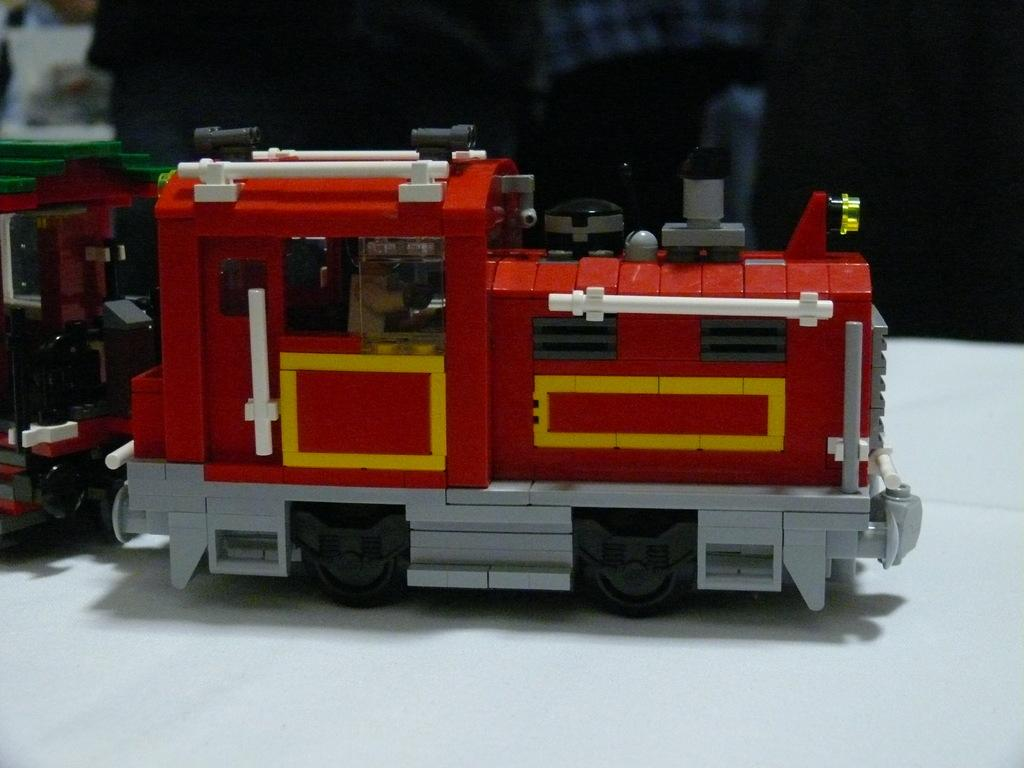What is the main subject of the image? The main subject of the image is a toy train. Is the toy train on any specific object? Yes, the toy train is on an object. Can you describe the background of the image? The background of the image is blurry. What type of birds can be seen flying in the image? There are no birds visible in the image; it features a toy train on an object with a blurry background. 